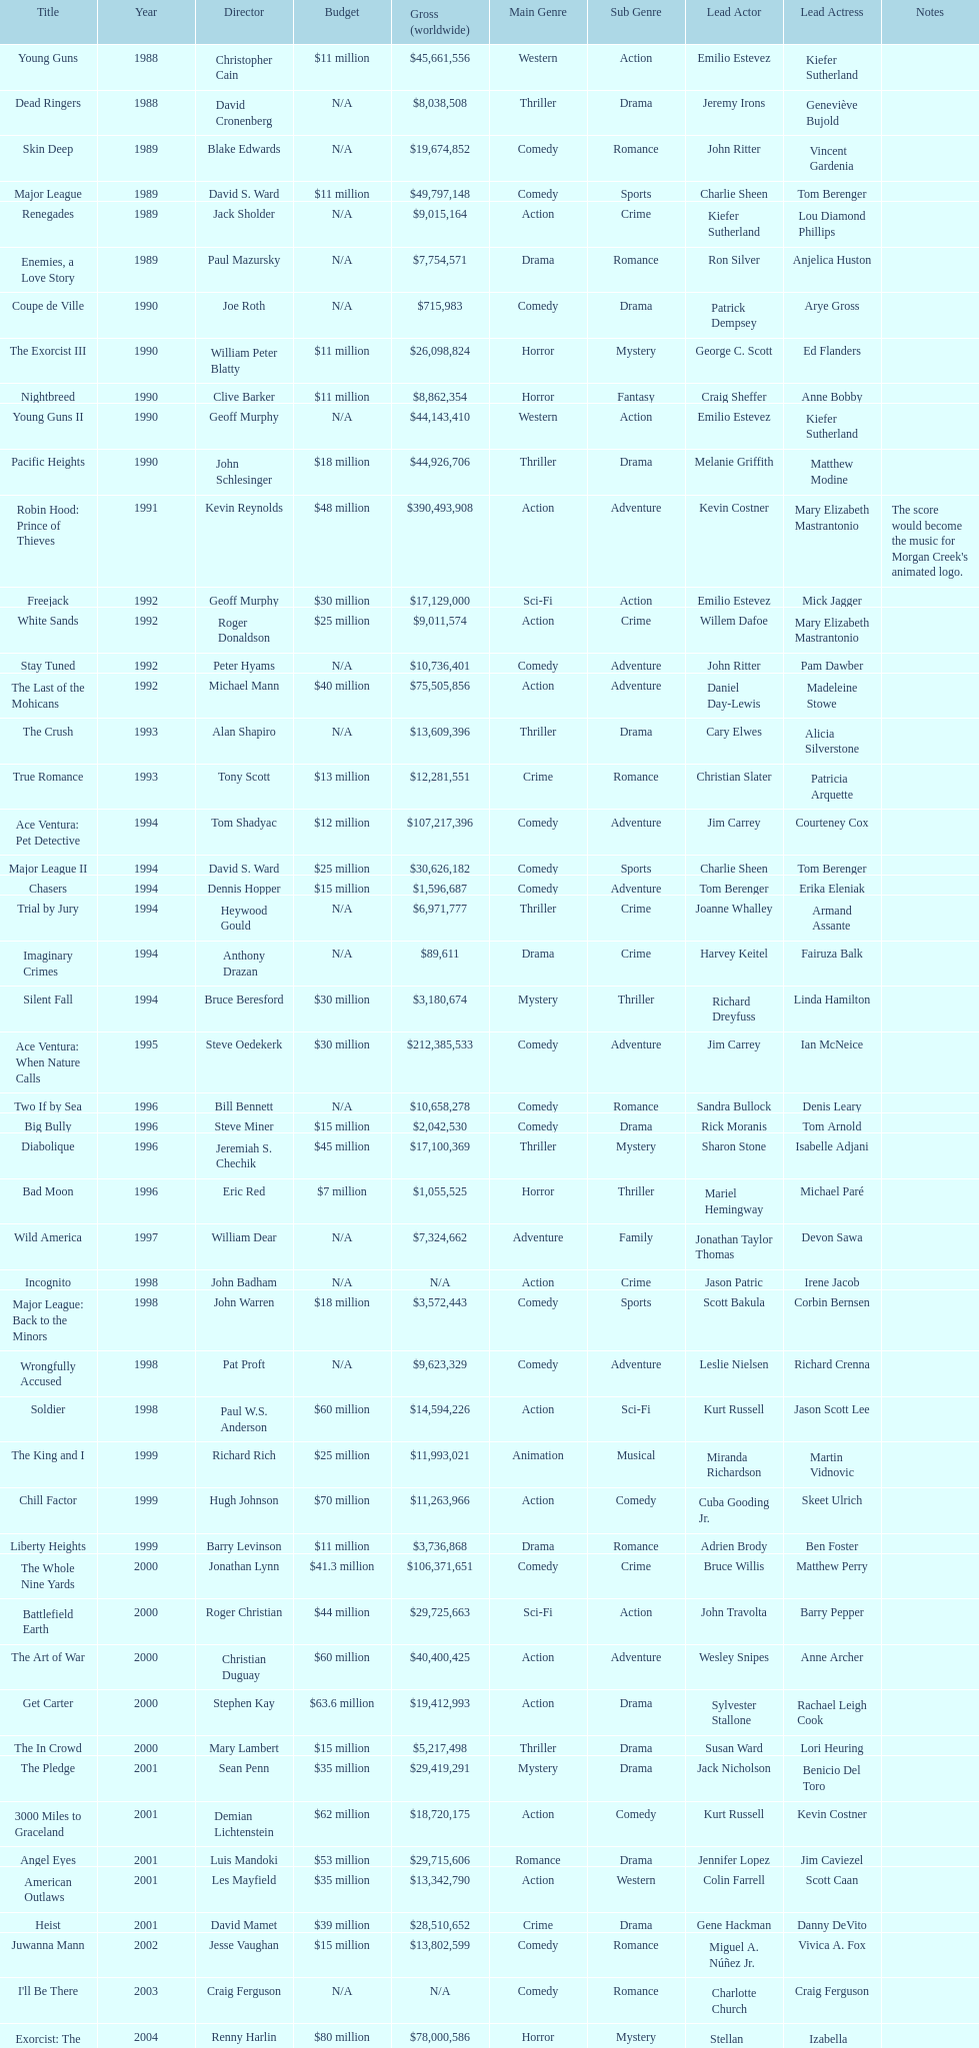What movie was made immediately before the pledge? The In Crowd. 